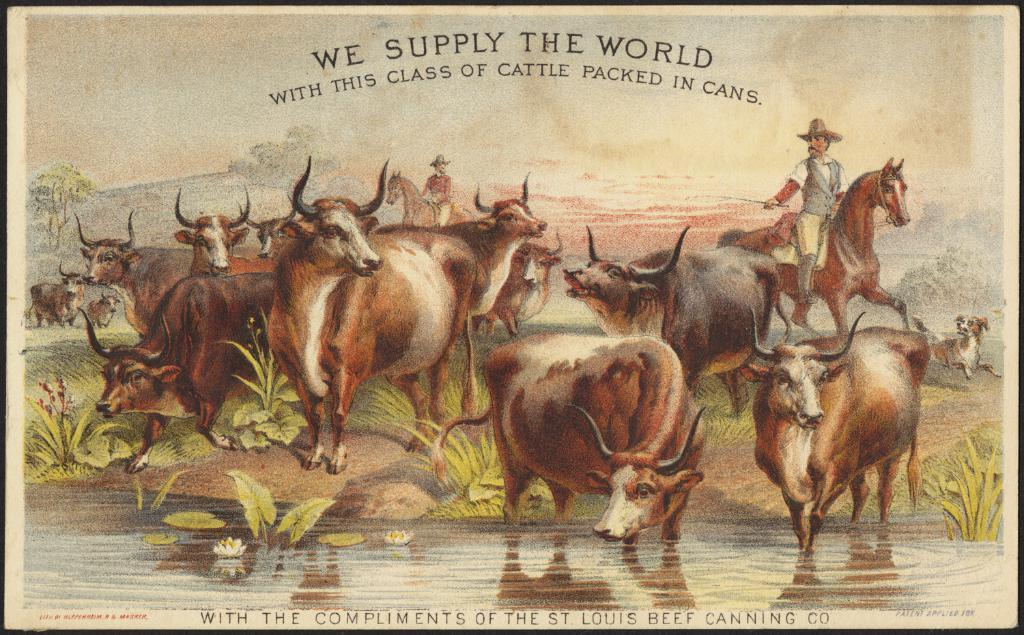What type of visual is depicted in the image? The image appears to be a poster. What can be seen in the middle of the poster? There are multiple animals in the middle of the poster. What is located at the bottom of the poster? There are plants and flowers, as well as water, visible at the bottom of the poster. What is written on the poster? There is text written at the top of the poster. Can you tell me how the animals are talking to each other in the image? The animals in the image are not talking to each other, as they are depicted in a static poster. What part of the brain is responsible for the creation of the poster? The poster is a visual representation, and the creation process involves various aspects of the brain, not just one specific part. 